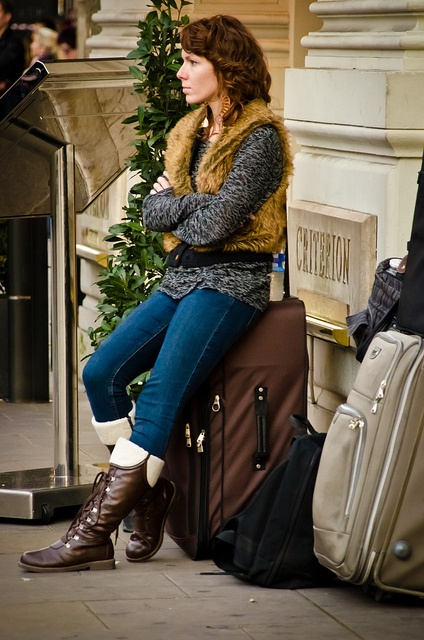Describe the objects in this image and their specific colors. I can see people in black, gray, maroon, and darkblue tones, suitcase in black, darkgray, and gray tones, suitcase in black, maroon, and gray tones, backpack in black, gray, and tan tones, and people in black, gray, and beige tones in this image. 